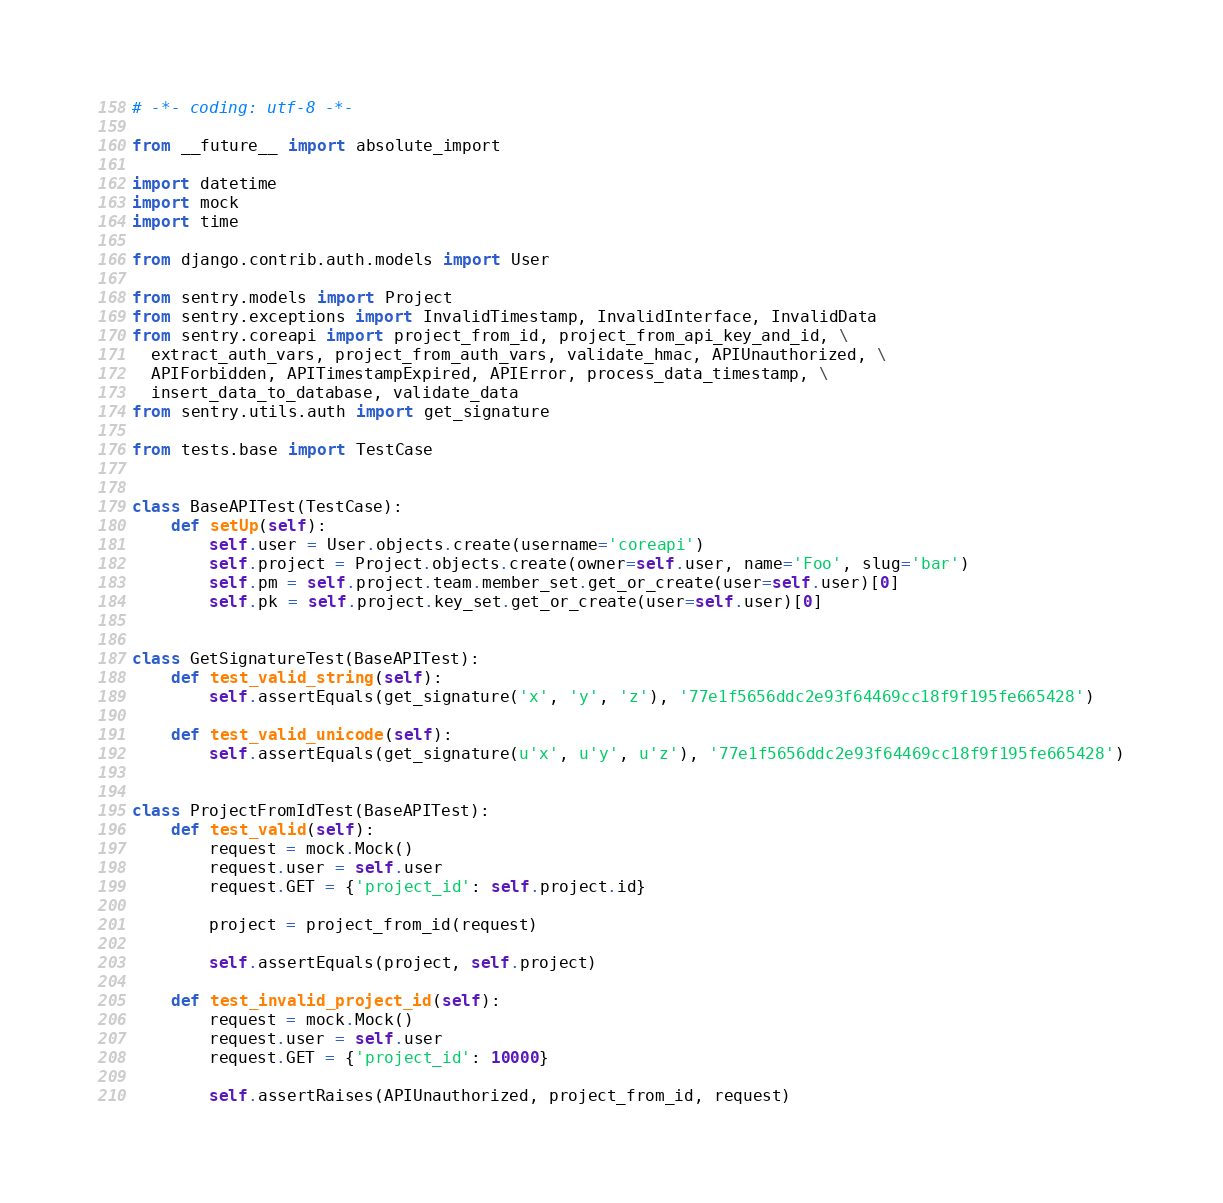<code> <loc_0><loc_0><loc_500><loc_500><_Python_># -*- coding: utf-8 -*-

from __future__ import absolute_import

import datetime
import mock
import time

from django.contrib.auth.models import User

from sentry.models import Project
from sentry.exceptions import InvalidTimestamp, InvalidInterface, InvalidData
from sentry.coreapi import project_from_id, project_from_api_key_and_id, \
  extract_auth_vars, project_from_auth_vars, validate_hmac, APIUnauthorized, \
  APIForbidden, APITimestampExpired, APIError, process_data_timestamp, \
  insert_data_to_database, validate_data
from sentry.utils.auth import get_signature

from tests.base import TestCase


class BaseAPITest(TestCase):
    def setUp(self):
        self.user = User.objects.create(username='coreapi')
        self.project = Project.objects.create(owner=self.user, name='Foo', slug='bar')
        self.pm = self.project.team.member_set.get_or_create(user=self.user)[0]
        self.pk = self.project.key_set.get_or_create(user=self.user)[0]


class GetSignatureTest(BaseAPITest):
    def test_valid_string(self):
        self.assertEquals(get_signature('x', 'y', 'z'), '77e1f5656ddc2e93f64469cc18f9f195fe665428')

    def test_valid_unicode(self):
        self.assertEquals(get_signature(u'x', u'y', u'z'), '77e1f5656ddc2e93f64469cc18f9f195fe665428')


class ProjectFromIdTest(BaseAPITest):
    def test_valid(self):
        request = mock.Mock()
        request.user = self.user
        request.GET = {'project_id': self.project.id}

        project = project_from_id(request)

        self.assertEquals(project, self.project)

    def test_invalid_project_id(self):
        request = mock.Mock()
        request.user = self.user
        request.GET = {'project_id': 10000}

        self.assertRaises(APIUnauthorized, project_from_id, request)
</code> 